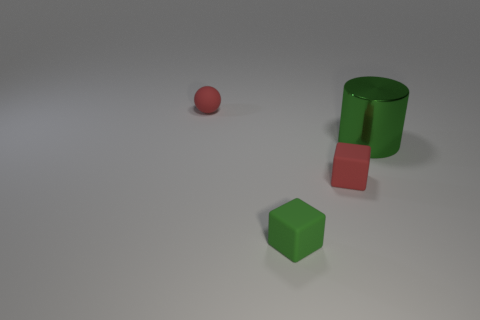How many other things are the same color as the metallic cylinder? In the image, there is one object that shares the same reddish-pink hue as the metallic cylinder, which is the small sphere. 